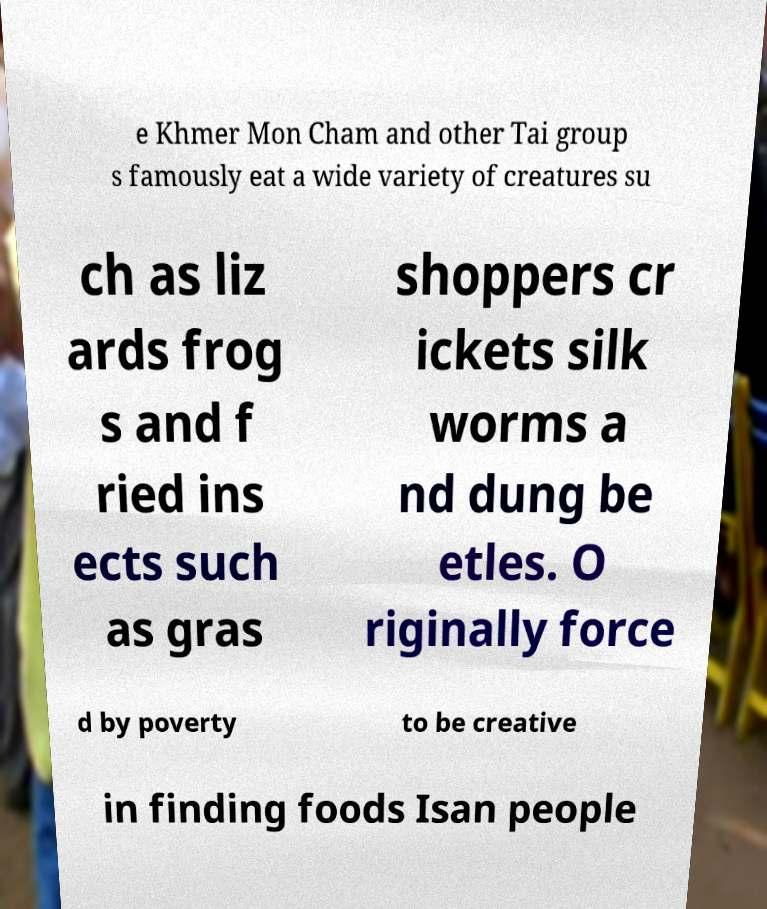I need the written content from this picture converted into text. Can you do that? e Khmer Mon Cham and other Tai group s famously eat a wide variety of creatures su ch as liz ards frog s and f ried ins ects such as gras shoppers cr ickets silk worms a nd dung be etles. O riginally force d by poverty to be creative in finding foods Isan people 